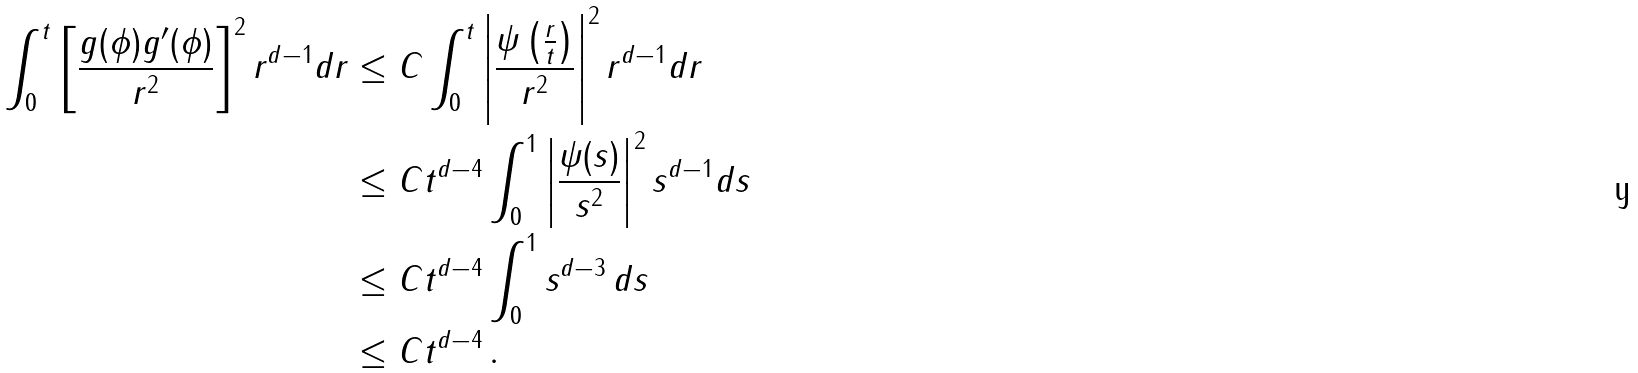<formula> <loc_0><loc_0><loc_500><loc_500>\int _ { 0 } ^ { t } \left [ \frac { g ( \phi ) g ^ { \prime } ( \phi ) } { r ^ { 2 } } \right ] ^ { 2 } r ^ { d - 1 } d r & \leq C \int _ { 0 } ^ { t } \left | \frac { \psi \left ( \frac { r } { t } \right ) } { r ^ { 2 } } \right | ^ { 2 } r ^ { d - 1 } d r \\ & \leq C t ^ { d - 4 } \int _ { 0 } ^ { 1 } \left | \frac { \psi ( s ) } { s ^ { 2 } } \right | ^ { 2 } s ^ { d - 1 } d s \\ & \leq C t ^ { d - 4 } \int _ { 0 } ^ { 1 } s ^ { d - 3 } \, d s \\ & \leq C t ^ { d - 4 } \, .</formula> 